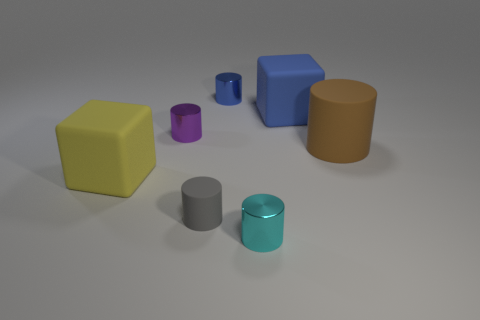What number of blocks are blue rubber objects or tiny cyan objects?
Make the answer very short. 1. What number of other things are there of the same material as the big brown cylinder
Ensure brevity in your answer.  3. There is a tiny shiny thing in front of the large brown cylinder; what is its shape?
Ensure brevity in your answer.  Cylinder. There is a block behind the rubber object that is on the left side of the tiny gray cylinder; what is its material?
Offer a very short reply. Rubber. Are there more cylinders that are on the left side of the small gray cylinder than large green metal spheres?
Give a very brief answer. Yes. What number of other objects are the same color as the large matte cylinder?
Offer a terse response. 0. What shape is the brown matte object that is the same size as the blue matte cube?
Provide a succinct answer. Cylinder. There is a block that is in front of the large thing behind the tiny purple metallic cylinder; how many big blue matte things are behind it?
Provide a short and direct response. 1. How many metallic objects are either brown cylinders or cyan cylinders?
Your response must be concise. 1. There is a matte object that is both on the right side of the yellow matte block and on the left side of the big blue matte block; what color is it?
Keep it short and to the point. Gray. 